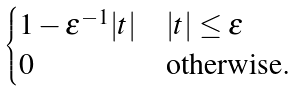<formula> <loc_0><loc_0><loc_500><loc_500>\begin{cases} 1 - \varepsilon ^ { - 1 } | t | & | t | \leq \varepsilon \\ 0 & \text {otherwise} . \end{cases}</formula> 